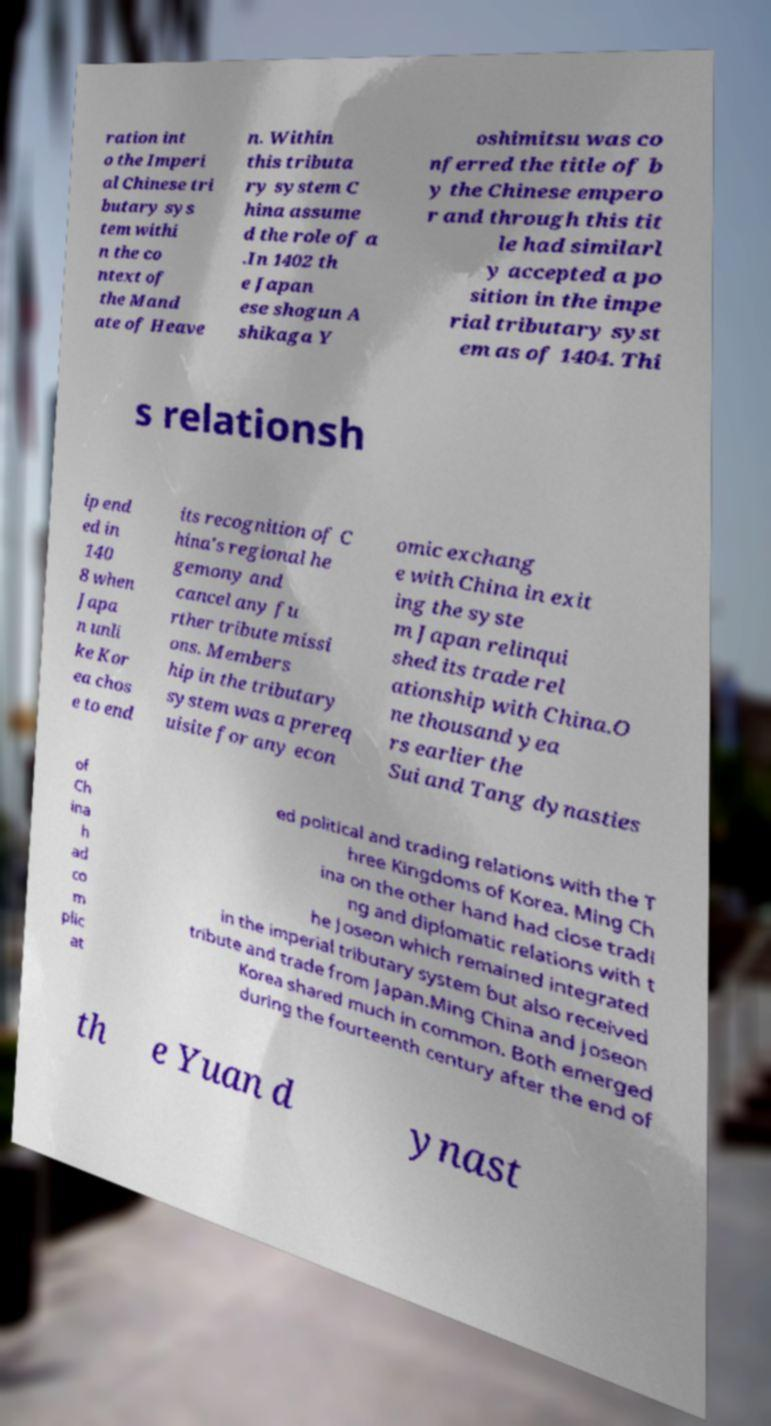Could you assist in decoding the text presented in this image and type it out clearly? ration int o the Imperi al Chinese tri butary sys tem withi n the co ntext of the Mand ate of Heave n. Within this tributa ry system C hina assume d the role of a .In 1402 th e Japan ese shogun A shikaga Y oshimitsu was co nferred the title of b y the Chinese empero r and through this tit le had similarl y accepted a po sition in the impe rial tributary syst em as of 1404. Thi s relationsh ip end ed in 140 8 when Japa n unli ke Kor ea chos e to end its recognition of C hina's regional he gemony and cancel any fu rther tribute missi ons. Members hip in the tributary system was a prereq uisite for any econ omic exchang e with China in exit ing the syste m Japan relinqui shed its trade rel ationship with China.O ne thousand yea rs earlier the Sui and Tang dynasties of Ch ina h ad co m plic at ed political and trading relations with the T hree Kingdoms of Korea. Ming Ch ina on the other hand had close tradi ng and diplomatic relations with t he Joseon which remained integrated in the imperial tributary system but also received tribute and trade from Japan.Ming China and Joseon Korea shared much in common. Both emerged during the fourteenth century after the end of th e Yuan d ynast 